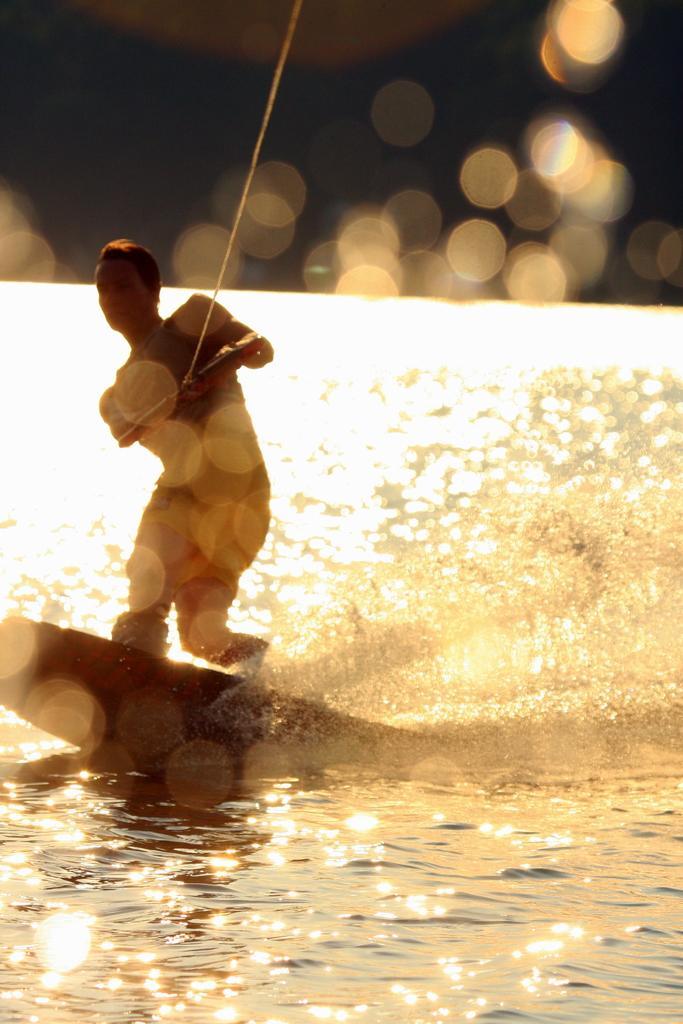Describe this image in one or two sentences. In this image, we can see a person holding an object and standing on the surfing board. At the bottom, there is water and at the top, there are lights. 